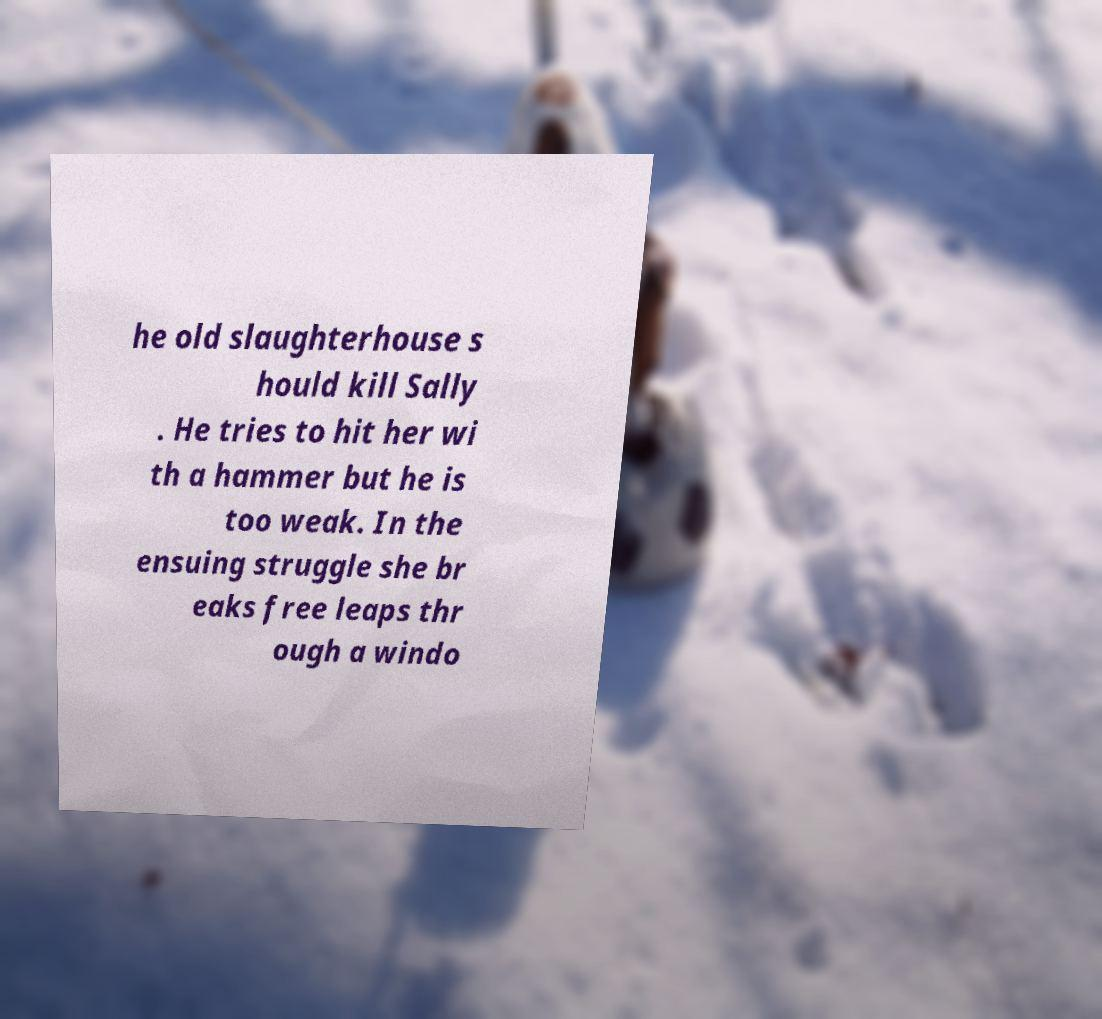Could you assist in decoding the text presented in this image and type it out clearly? he old slaughterhouse s hould kill Sally . He tries to hit her wi th a hammer but he is too weak. In the ensuing struggle she br eaks free leaps thr ough a windo 